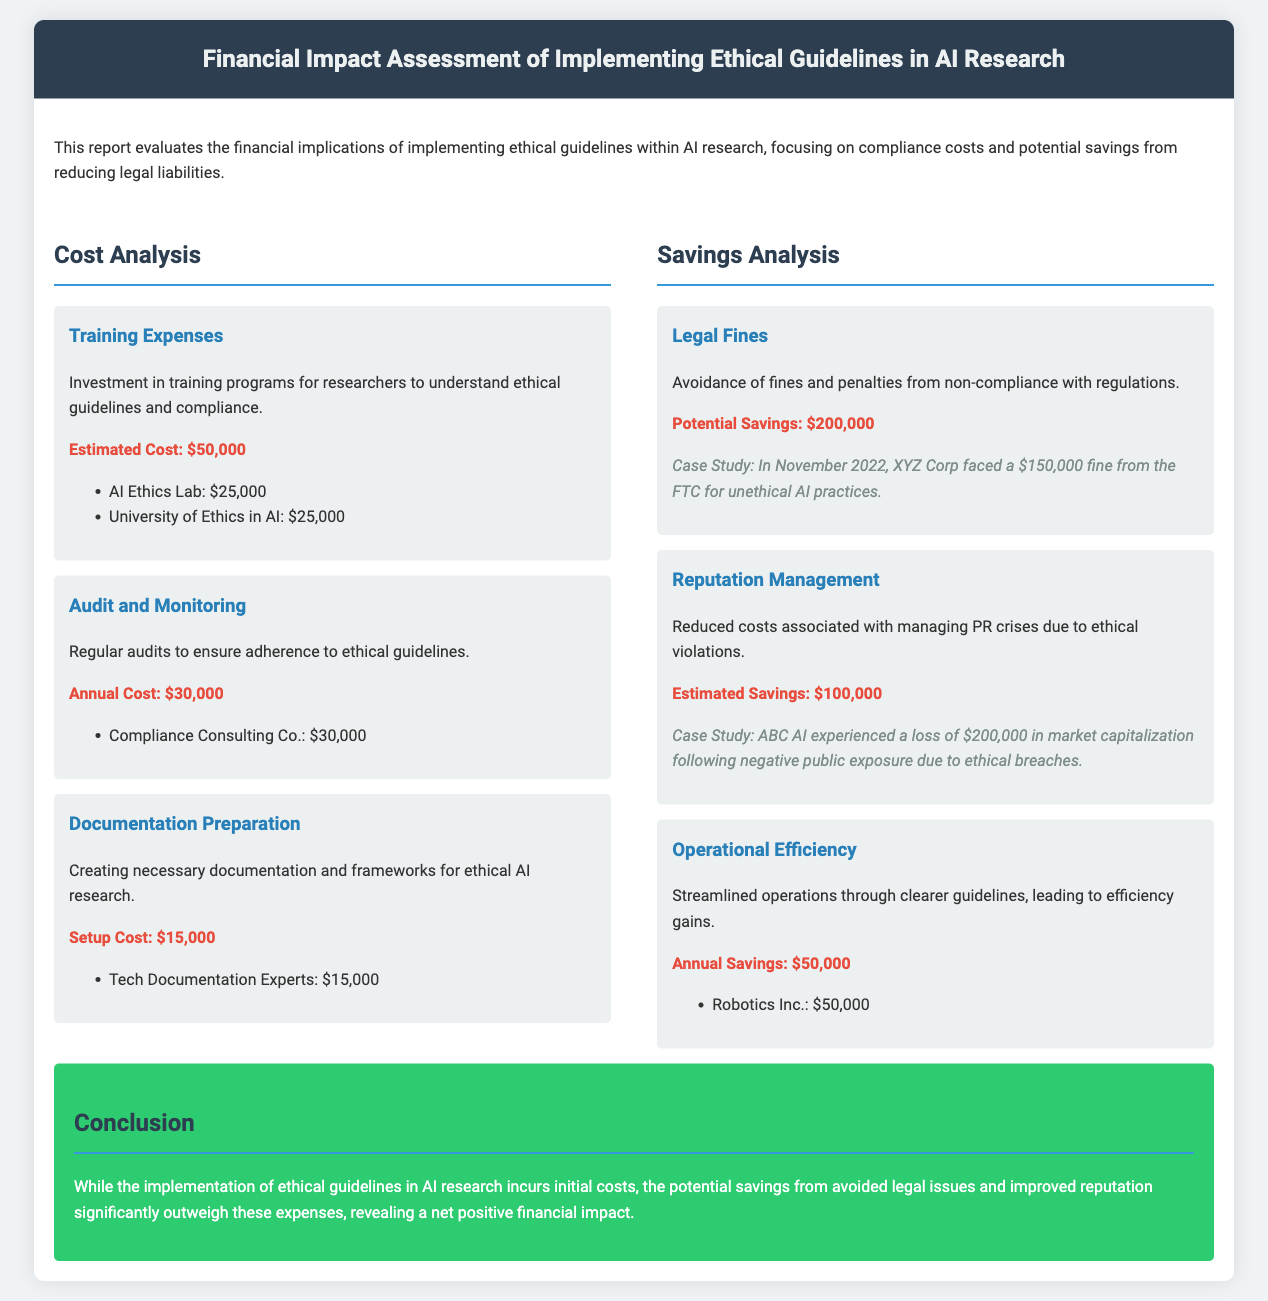What is the estimated cost for training expenses? The document states that the estimated cost for training expenses is $50,000.
Answer: $50,000 What is the annual cost of audit and monitoring? The annual cost for audits to ensure adherence to ethical guidelines is mentioned as $30,000.
Answer: $30,000 What are the potential savings from avoiding legal fines? The potential savings from legal fines mentioned in the report is $200,000.
Answer: $200,000 What is the estimated savings related to reputation management? The estimated savings associated with managing PR crises due to ethical violations is identified as $100,000.
Answer: $100,000 What is the setup cost for documentation preparation? According to the report, the setup cost for documentation preparation is $15,000.
Answer: $15,000 What is the total initial cost of implementing the ethical guidelines? The total initial cost includes training expenses, documentation preparation, and the first year's audit, which sums up to $95,000.
Answer: $95,000 What is the annual savings from operational efficiency? The document specifies the annual savings from operational efficiency as $50,000.
Answer: $50,000 Which case study mentions a $150,000 fine? The case study mentions XYZ Corp, which faced a $150,000 fine from the FTC for unethical AI practices.
Answer: XYZ Corp What is the document's conclusion regarding the financial impact of implementing ethical guidelines? The conclusion summarizes that the potential savings from avoided legal issues significantly outweigh the costs, revealing a net positive financial impact.
Answer: Net positive financial impact 